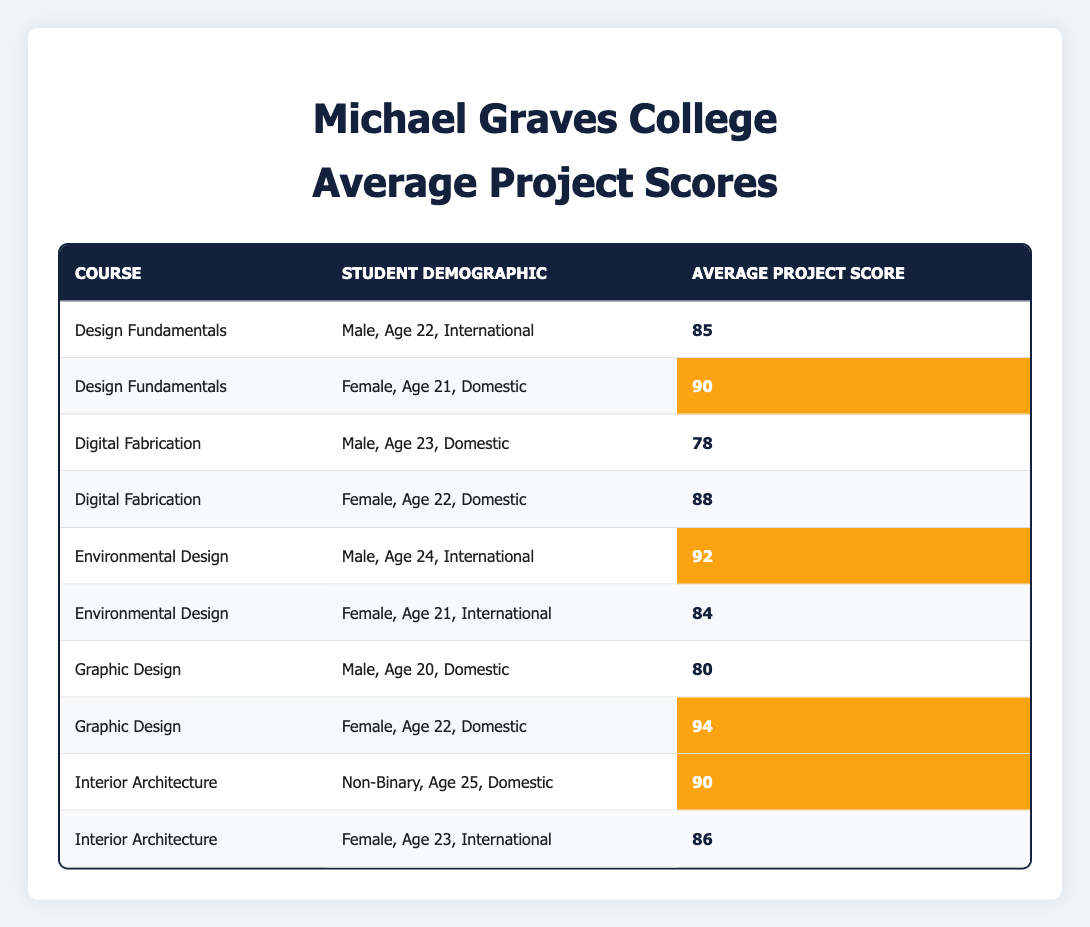What is the average project score for "Graphic Design"? The average project score for "Graphic Design" can be found by looking at the scores listed under that course. The scores are 80 for Male, Age 20, Domestic and 94 for Female, Age 22, Domestic. Adding these scores gives 80 + 94 = 174. There are 2 students, so the average is 174 / 2 = 87.
Answer: 87 Which demographic has the highest average project score in "Environmental Design"? In "Environmental Design," there are two demographics: Male, Age 24, International with a score of 92 and Female, Age 21, International with a score of 84. Comparing these two scores, 92 is higher than 84, so the Male demographic has the highest average score.
Answer: Male, Age 24, International Did any female students score below 85 in their projects? By examining the scores for female students, we see that the only values are 90 (Design Fundamentals), 88 (Digital Fabrication), 84 (Environmental Design), 94 (Graphic Design), and 86 (Interior Architecture). The lowest score among these is 84, which is below 85. Therefore, yes, female students did score below 85.
Answer: Yes What is the total average project score for all courses combined? To find the total average project score, we first identify all the individual scores: 85, 90, 78, 88, 92, 84, 80, 94, 90, 86. Adding them gives a total of 85 + 90 + 78 + 88 + 92 + 84 + 80 + 94 + 90 + 86 =  915. There are 10 scores, so the average is 915 / 10 = 91.5.
Answer: 91.5 Which course had the highest individual average project score, and what was that score? We look at the average project scores for each course: Design Fundamentals (90), Digital Fabrication (88), Environmental Design (92), Graphic Design (94), and Interior Architecture (90). The highest score is recorded in Graphic Design at 94.
Answer: Graphic Design, 94 